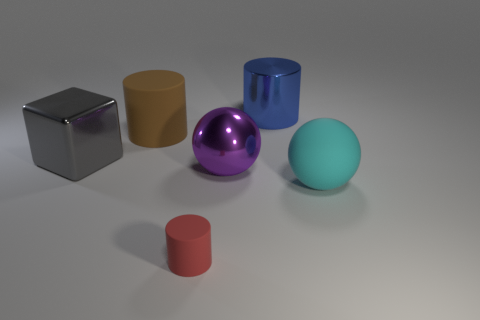Is there any other thing that has the same size as the red cylinder?
Give a very brief answer. No. Is there any other thing that is the same material as the big cube?
Offer a terse response. Yes. Is the size of the cyan matte sphere the same as the matte cylinder behind the large purple sphere?
Your answer should be compact. Yes. What number of other things are there of the same color as the tiny object?
Provide a short and direct response. 0. Are there any cyan matte spheres to the left of the big purple metallic thing?
Keep it short and to the point. No. How many things are gray shiny cylinders or objects right of the red cylinder?
Provide a succinct answer. 3. There is a large matte object right of the shiny cylinder; are there any large blue metal cylinders in front of it?
Your answer should be very brief. No. What is the shape of the rubber thing on the right side of the cylinder that is in front of the brown matte cylinder that is left of the big blue object?
Ensure brevity in your answer.  Sphere. What is the color of the object that is on the right side of the big block and to the left of the tiny rubber object?
Ensure brevity in your answer.  Brown. There is a metallic thing that is in front of the large metal block; what shape is it?
Ensure brevity in your answer.  Sphere. 